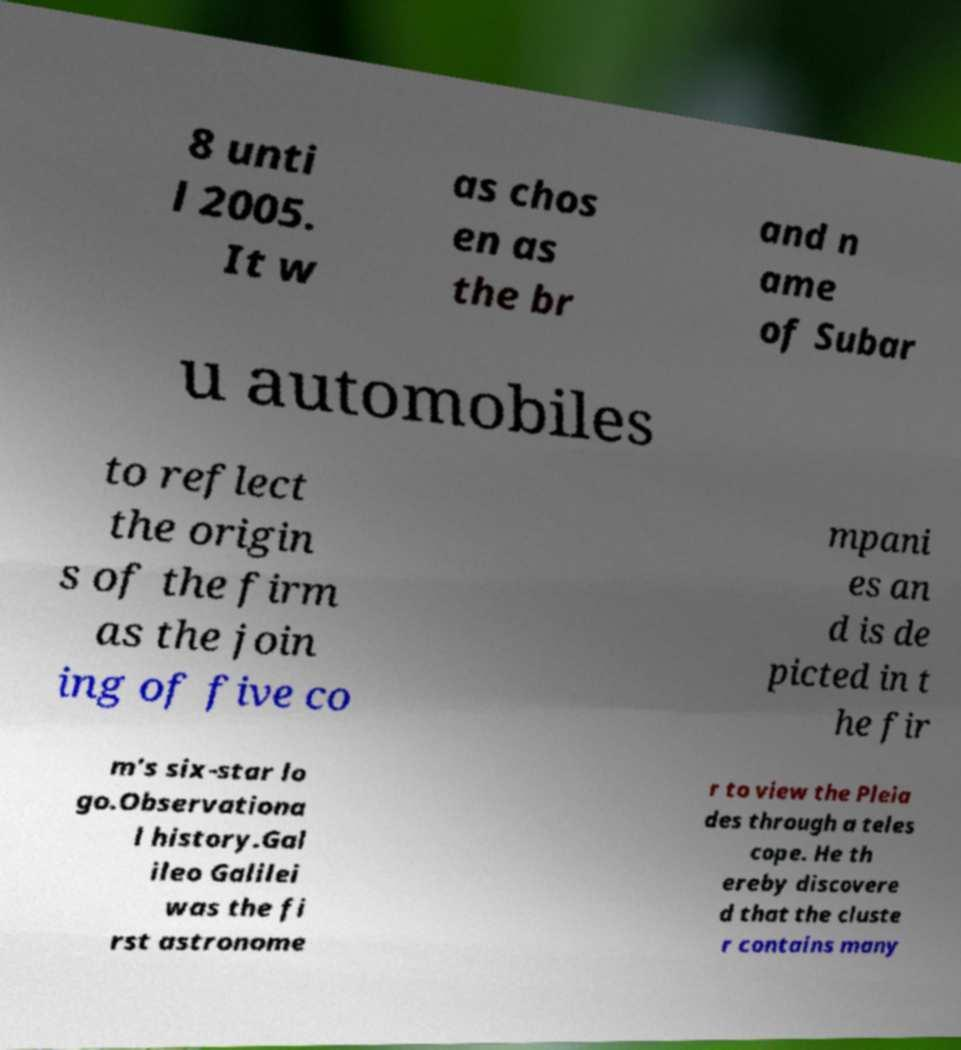For documentation purposes, I need the text within this image transcribed. Could you provide that? 8 unti l 2005. It w as chos en as the br and n ame of Subar u automobiles to reflect the origin s of the firm as the join ing of five co mpani es an d is de picted in t he fir m's six-star lo go.Observationa l history.Gal ileo Galilei was the fi rst astronome r to view the Pleia des through a teles cope. He th ereby discovere d that the cluste r contains many 